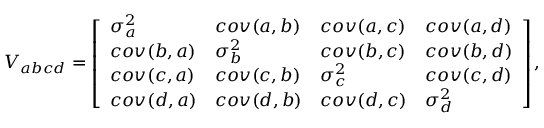Convert formula to latex. <formula><loc_0><loc_0><loc_500><loc_500>\begin{array} { r } { V _ { a b c d } = \left [ \begin{array} { l l l l } { \sigma _ { a } ^ { 2 } } & { c o v ( a , b ) } & { c o v ( a , c ) } & { c o v ( a , d ) } \\ { c o v ( b , a ) } & { \sigma _ { b } ^ { 2 } } & { c o v ( b , c ) } & { c o v ( b , d ) } \\ { c o v ( c , a ) } & { c o v ( c , b ) } & { \sigma _ { c } ^ { 2 } } & { c o v ( c , d ) } \\ { c o v ( d , a ) } & { c o v ( d , b ) } & { c o v ( d , c ) } & { \sigma _ { d } ^ { 2 } } \end{array} \right ] , } \end{array}</formula> 